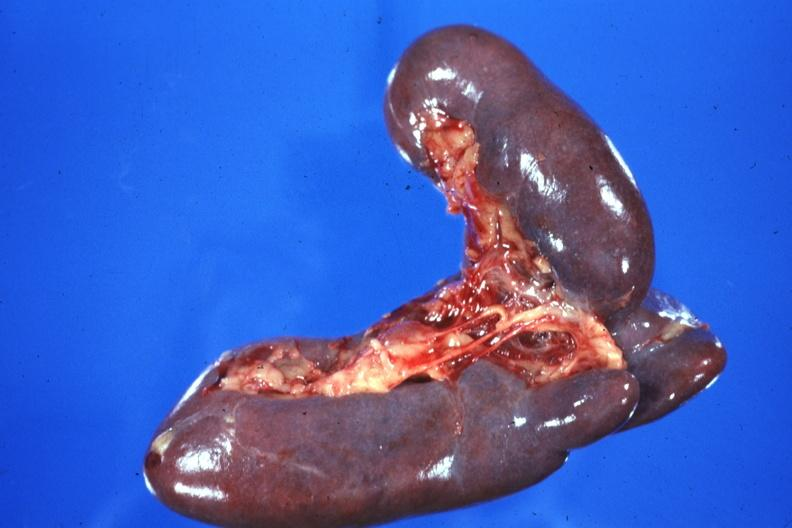does this image show external view case of situs ambiguous partial left isomerism?
Answer the question using a single word or phrase. Yes 